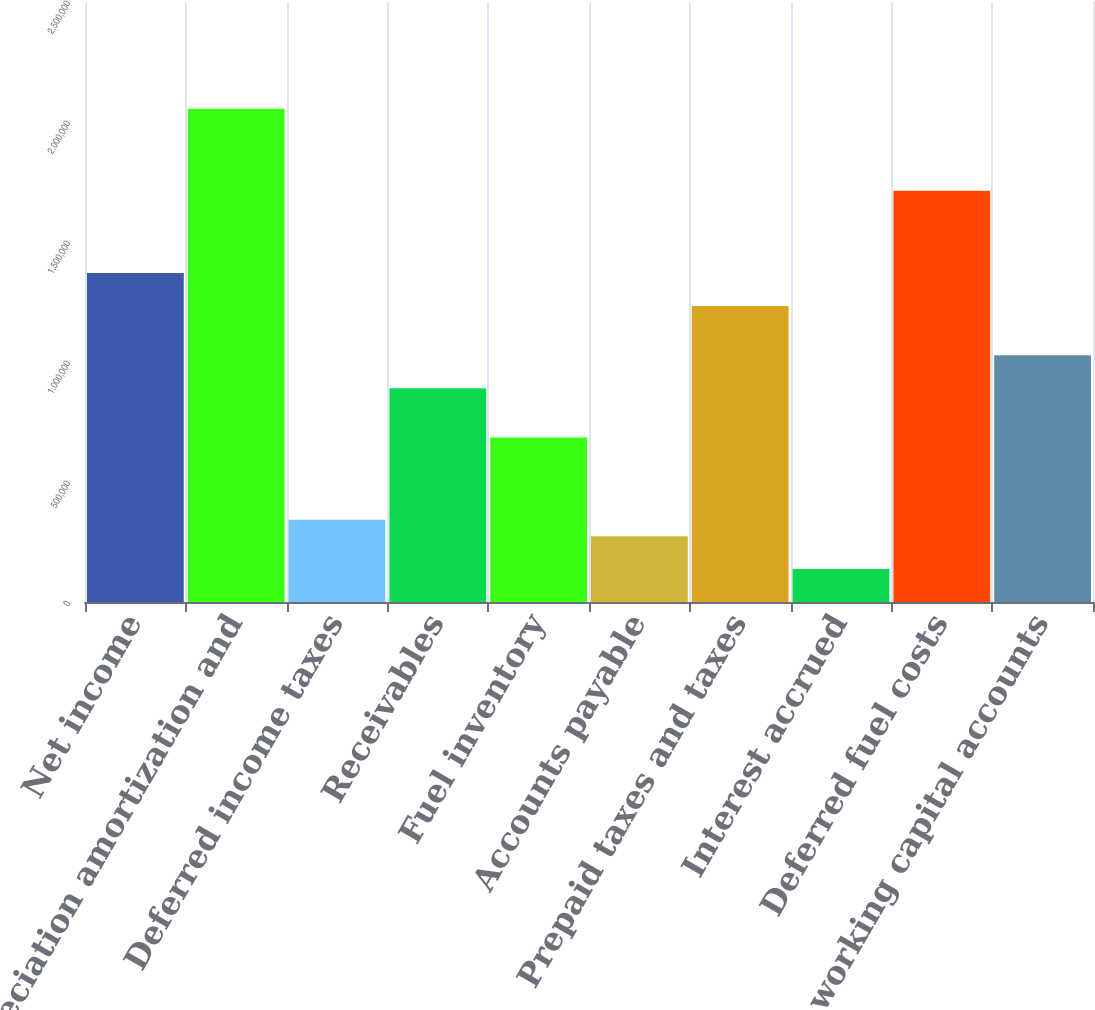<chart> <loc_0><loc_0><loc_500><loc_500><bar_chart><fcel>Net income<fcel>Depreciation amortization and<fcel>Deferred income taxes<fcel>Receivables<fcel>Fuel inventory<fcel>Accounts payable<fcel>Prepaid taxes and taxes<fcel>Interest accrued<fcel>Deferred fuel costs<fcel>Other working capital accounts<nl><fcel>1.37044e+06<fcel>2.05561e+06<fcel>342691<fcel>890824<fcel>685274<fcel>274174<fcel>1.23341e+06<fcel>137141<fcel>1.71302e+06<fcel>1.02786e+06<nl></chart> 